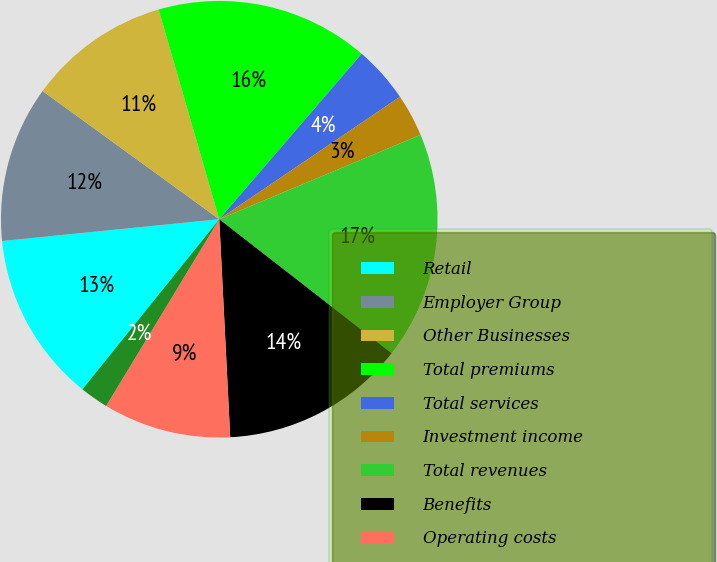<chart> <loc_0><loc_0><loc_500><loc_500><pie_chart><fcel>Retail<fcel>Employer Group<fcel>Other Businesses<fcel>Total premiums<fcel>Total services<fcel>Investment income<fcel>Total revenues<fcel>Benefits<fcel>Operating costs<fcel>Depreciation and amortization<nl><fcel>12.63%<fcel>11.58%<fcel>10.53%<fcel>15.79%<fcel>4.21%<fcel>3.16%<fcel>16.84%<fcel>13.68%<fcel>9.47%<fcel>2.11%<nl></chart> 